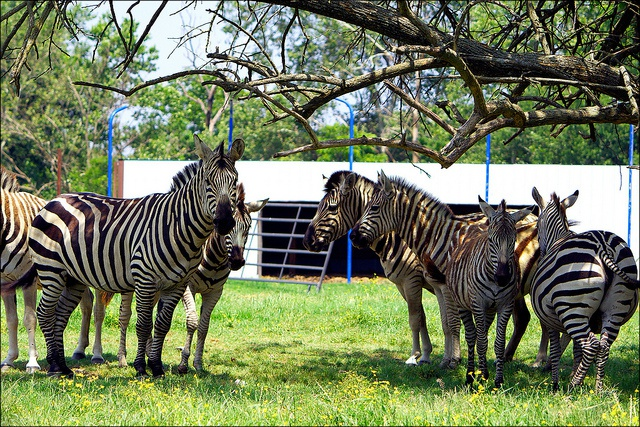Describe the objects in this image and their specific colors. I can see zebra in black, gray, darkgray, and darkgreen tones, zebra in black, gray, darkgray, and darkgreen tones, zebra in black, gray, and darkgreen tones, zebra in black and gray tones, and zebra in black, darkgreen, and gray tones in this image. 